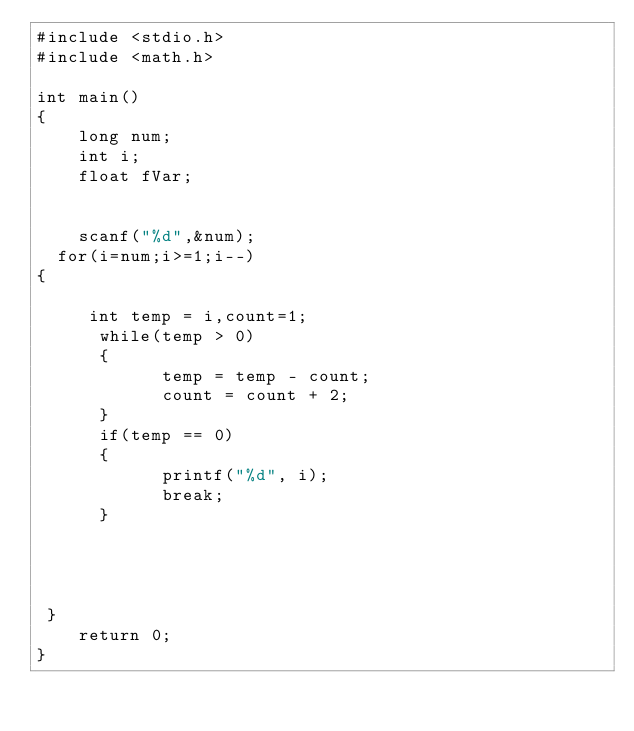<code> <loc_0><loc_0><loc_500><loc_500><_C_>#include <stdio.h>
#include <math.h>
 
int main()
{
    long num;
    int i;
    float fVar;
  
   
    scanf("%d",&num);
  for(i=num;i>=1;i--)
{
    
     int temp = i,count=1;
      while(temp > 0)
      {
            temp = temp - count;
            count = count + 2;
      }
      if(temp == 0)
      {
            printf("%d", i);
            break;
      }
      

 
    
 }  
    return 0;
}</code> 